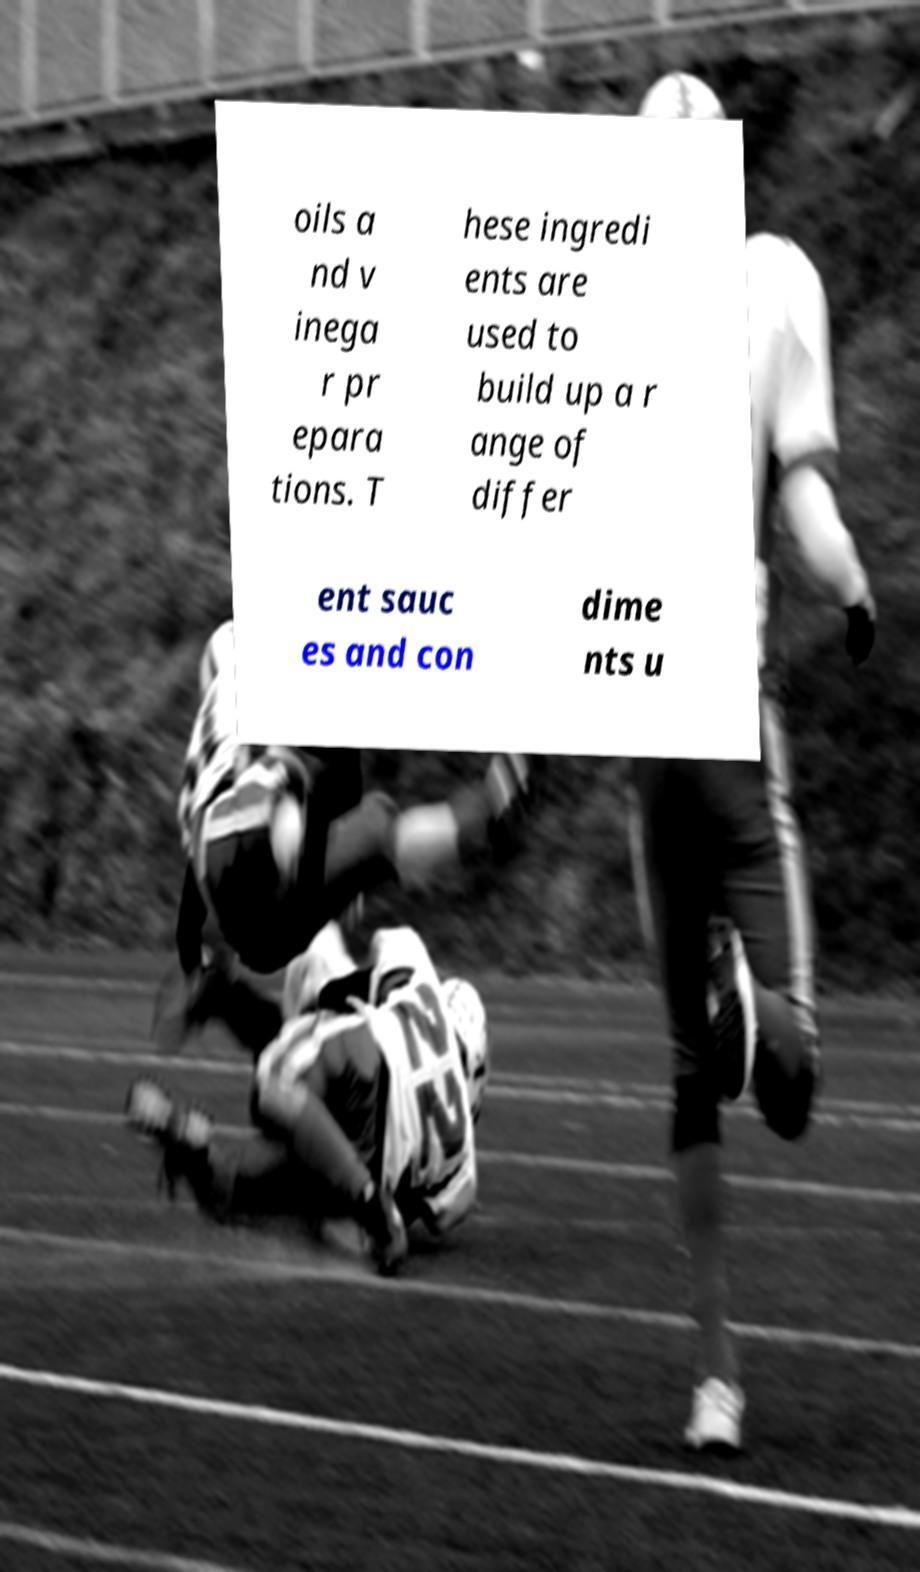Can you accurately transcribe the text from the provided image for me? oils a nd v inega r pr epara tions. T hese ingredi ents are used to build up a r ange of differ ent sauc es and con dime nts u 